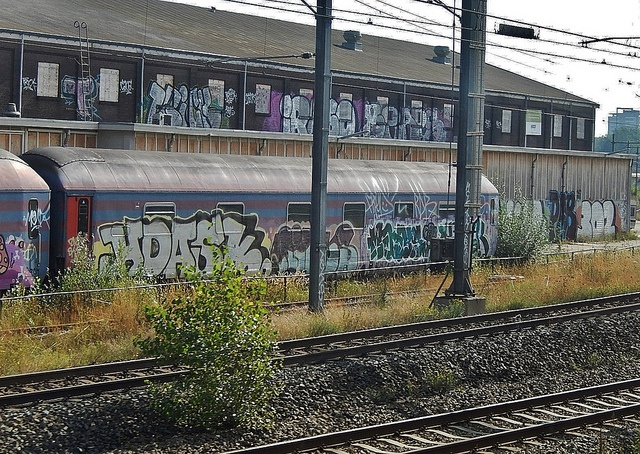Describe the objects in this image and their specific colors. I can see a train in gray, darkgray, black, and blue tones in this image. 